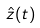<formula> <loc_0><loc_0><loc_500><loc_500>\hat { z } ( t )</formula> 